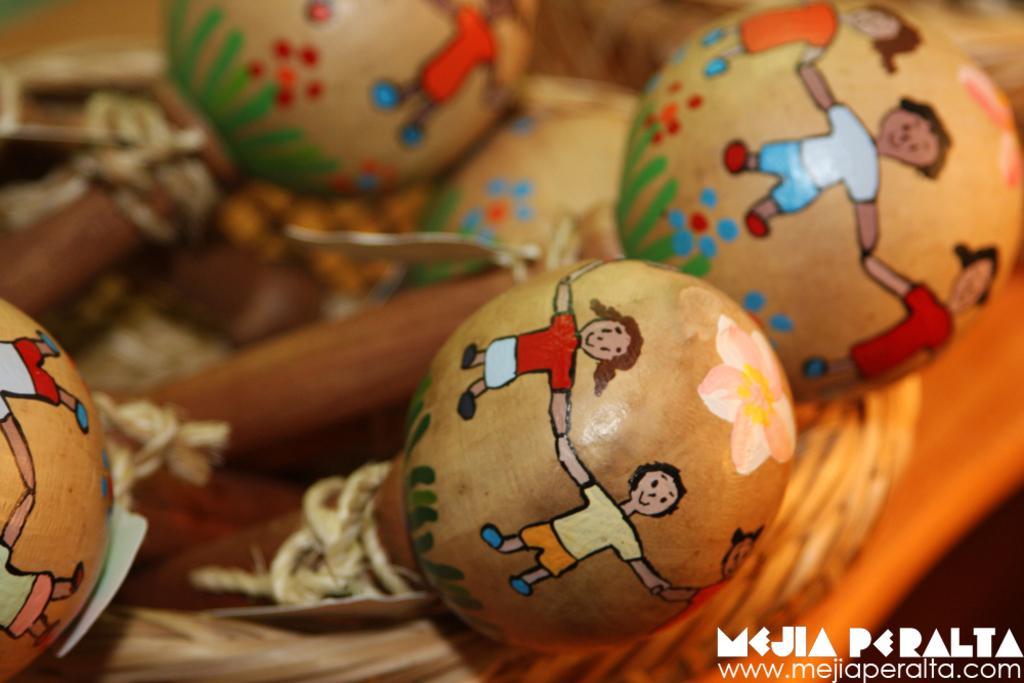In one or two sentences, can you explain what this image depicts? In this picture I can see maracas-es with paintings on it, in a basket, and there is blur background and there is a watermark on the image. 